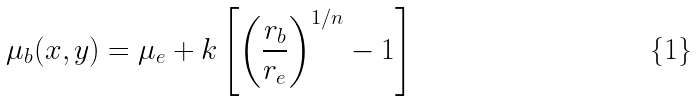Convert formula to latex. <formula><loc_0><loc_0><loc_500><loc_500>\mu _ { b } ( x , y ) = \mu _ { e } + k \left [ \left ( \frac { r _ { b } } { r _ { e } } \right ) ^ { 1 / n } - 1 \right ]</formula> 